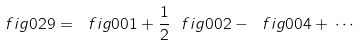Convert formula to latex. <formula><loc_0><loc_0><loc_500><loc_500>\ f i g { 0 2 9 } = \ f i g { 0 0 1 } + \frac { 1 } { 2 } \ f i g { 0 0 2 } - \ f i g { 0 0 4 } + \, \cdots</formula> 